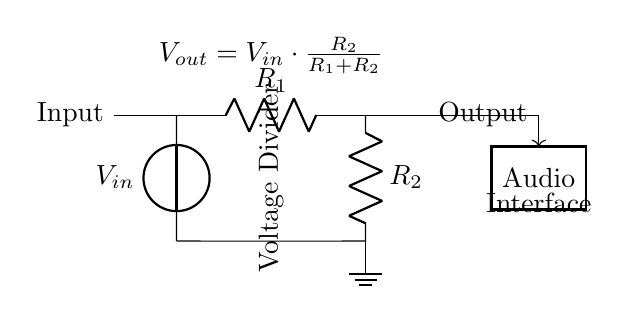What type of circuit is shown? The circuit is a voltage divider circuit, which is used to reduce the voltage to a desired level.
Answer: Voltage divider What is the formula for output voltage? The formula displayed in the circuit shows how to calculate the output voltage based on the input voltage and resistor values. Specifically, it reads: Voltage_out equals Voltage_in multiplied by R2 divided by (R1 plus R2).
Answer: Voltage_out = Voltage_in × R2 / (R1 + R2) What is the role of R1 in the circuit? R1 is one of the resistors in the voltage divider that contributes to determining the output voltage alongside R2. It works in conjunction with R2 to proportionately reduce the input voltage.
Answer: Voltage reduction What is the connection of the output in the circuit? The output is taken from the point between resistors R1 and R2, which allows the output voltage to be a fraction of the input voltage.
Answer: Between R1 and R2 If R1 is doubled, how does it affect V_out? Doubling R1 will increase the total resistance in the voltage divider, which, according to the formula, will decrease the output voltage for a constant input voltage. More specifically, this will change the ratio of R2 to (R1 + R2).
Answer: Decrease V_out What component allows the adjustable output in this circuit? The combination of resistors R1 and R2 allows for the adjustment of the output voltage, enabling the circuit to tailor voltage levels as required for the audio interface.
Answer: Resistors R1 and R2 What happens to the output voltage if R2 is very small? If R2 becomes very small, the output voltage will approach nearly zero, as the voltage drop across R2 will decrease significantly compared to R1. The circuit will then output a much smaller voltage.
Answer: Approach zero 